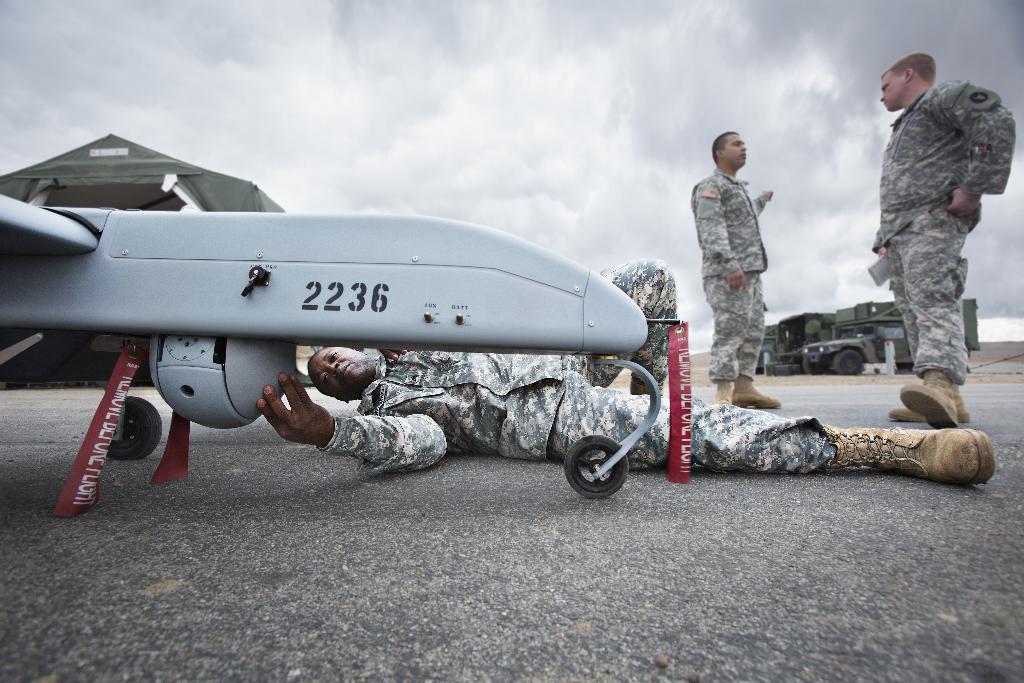What number is on the plane?
Offer a terse response. 2236. 